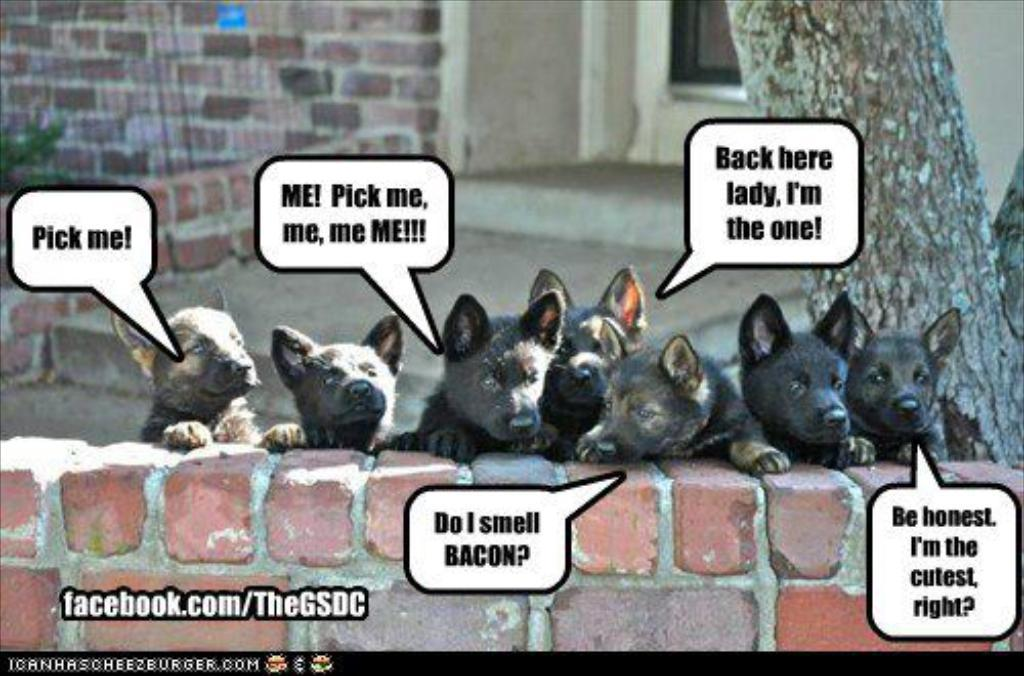What types of living organisms can be seen in the image? There are animals in the image. What are the animals doing in the image? The animals are leaning on a wall and watching on the other side. What kind of structure is present in the image? There is a brick wall in the image. What other natural element can be seen in the image? There is a tree in the image. What type of feather can be seen floating in the air in the image? There is no feather present in the image; it only features animals, a brick wall, and a tree. 